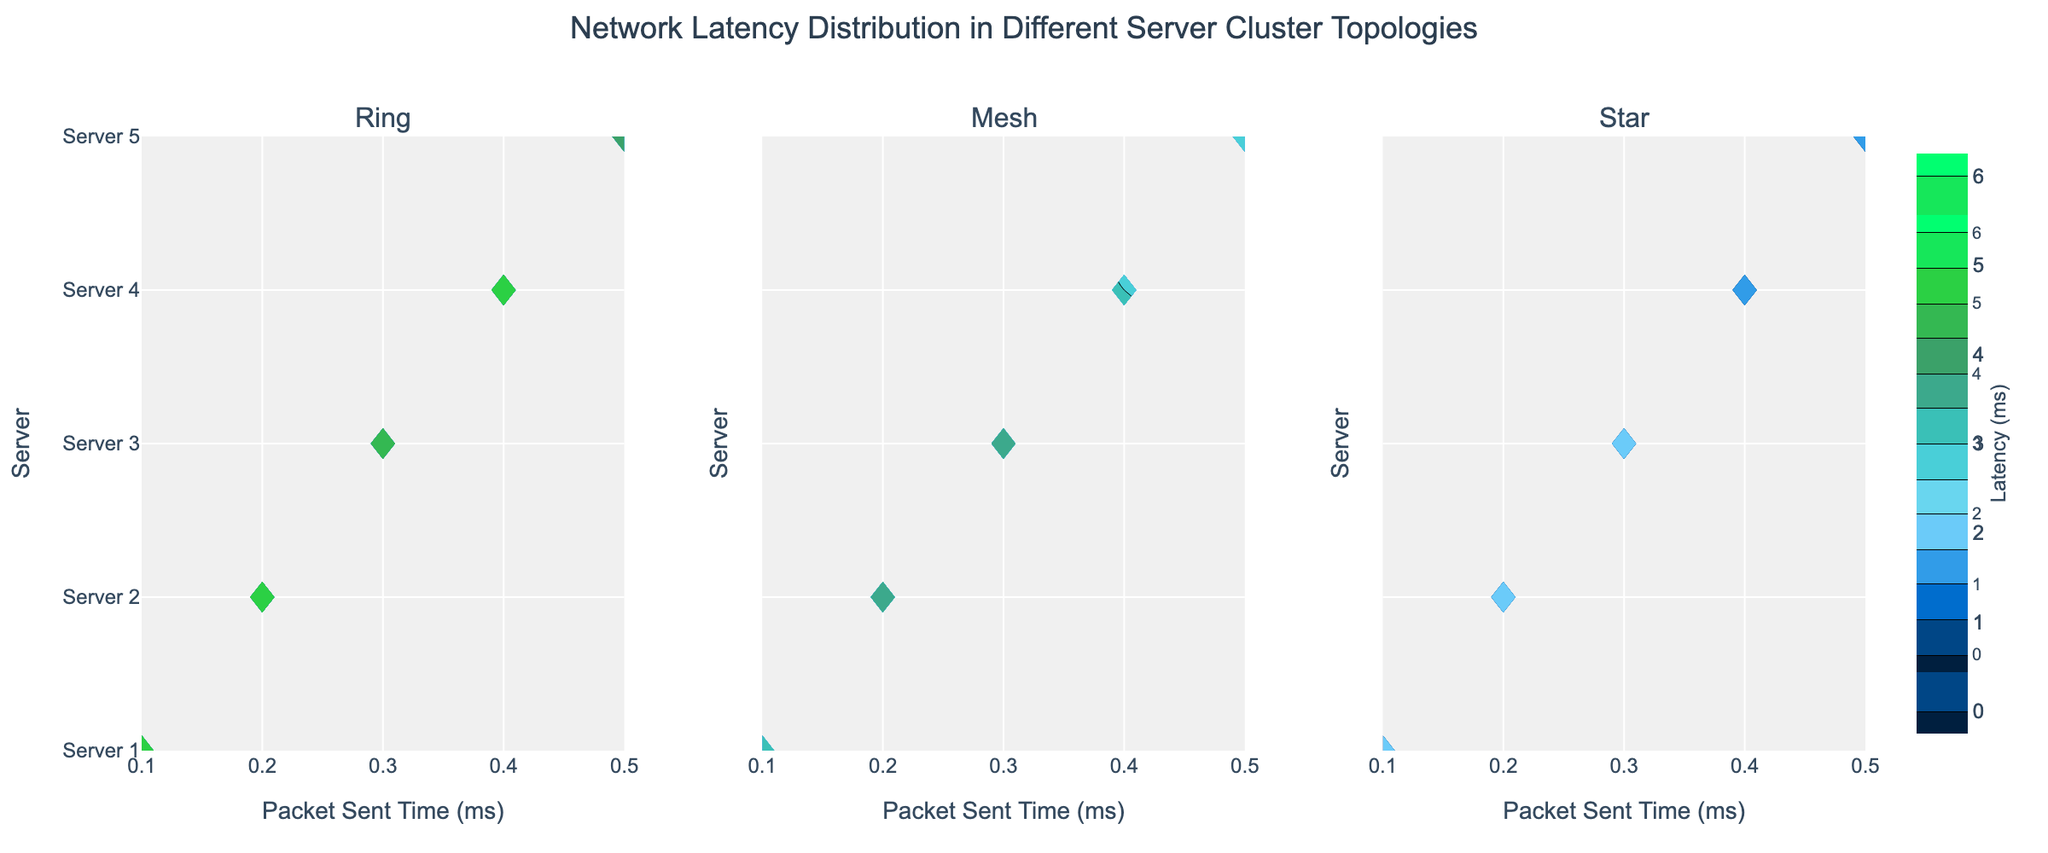How many different topologies are shown in the figure? By looking at the subplot titles, we can identify that there are three different topologies: Ring, Mesh, and Star.
Answer: 3 Which topology shows the lowest maximum latency among all servers? We can observe and compare the highest contour lines across the three subplots. The Star topology has the lowest maximum latency, evident from the contour lines not exceeding 2 ms.
Answer: Star What is the approximate range of latencies for the Ring topology? Looking at the contour lines for the Ring topology, the latency values range from around 4.2 ms to 5.5 ms.
Answer: 4.2 ms to 5.5 ms Which server in the Mesh topology has the highest latency? By examining the contour lines for the Mesh subplot, Server 3 shows the highest latency, indicated by contour lines that reach around 3.9 ms.
Answer: Server 3 Is the latency distribution more uniform in the Ring topology or the Mesh topology? In the Mesh topology, the latencies are more uniformly distributed across servers compared to the Ring topology, where significant variation is seen between servers. This can be observed through the spacing and positioning of the contour lines.
Answer: Mesh What is the contour color representing the lowest latency in the Star topology? The contour colors are shown in a gradient, where the color for the lowest latency in the Star topology appears to be a shade of green.
Answer: Green For the Ring topology, which server experiences the lowest latency? By observing the contour lines in the Ring topology subplot, Server 5 experiences the lowest latency, shown by the contour lines reaching the value of around 4.2 ms.
Answer: Server 5 What is the general trend of latency as the Packet Sent Time increases in each topology? In each topology, as Packet Sent Time increases from 0.1 ms to 0.5 ms, the latency tends to increase. This trend is visible by the rising contour lines from left to right in all subplots.
Answer: Latency increases Compare the highest latency between Server 2s in different topologies. Analyzing the contour lines, Server 2 in the Ring topology shows a higher maximum latency (~5.3 ms) compared to Mesh (~3.8 ms) and Star (~1.9 ms) topologies.
Answer: Ring How does the latency variance compare among different topologies? The contour lines for the Ring topology vary more significantly (around 4.2 ms to 5.5 ms) compared to the Mesh (2.7 ms to 3.9 ms) and Star (1.0 ms to 2.0 ms) topologies, indicating higher variance in the Ring topology.
Answer: Higher in Ring 